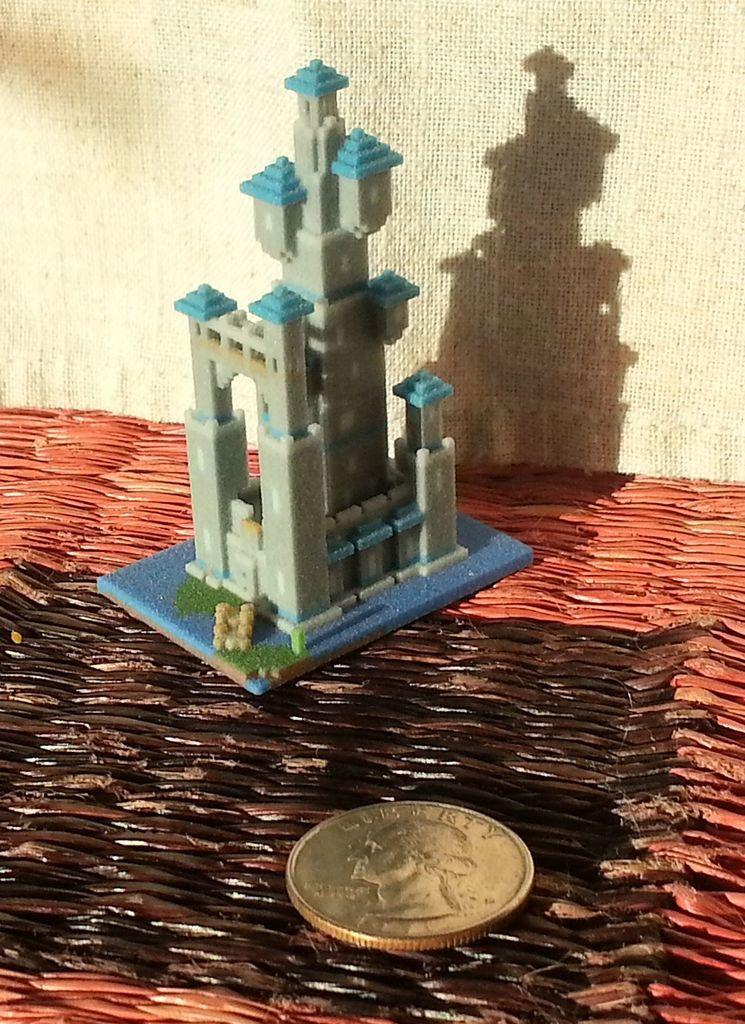Please provide a concise description of this image. Here we can see toy building and coin on the surface. Background it is cream color. 